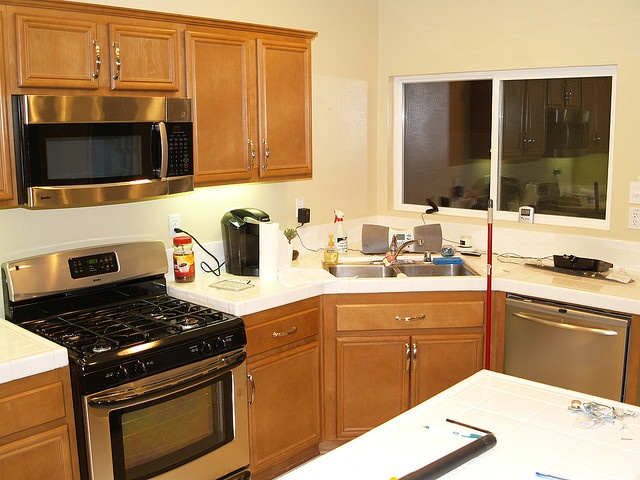Describe the objects in this image and their specific colors. I can see oven in brown, black, olive, and tan tones, microwave in brown, black, and gray tones, refrigerator in brown, gray, olive, and tan tones, sink in brown, gray, tan, and darkgray tones, and clock in brown, black, and gray tones in this image. 